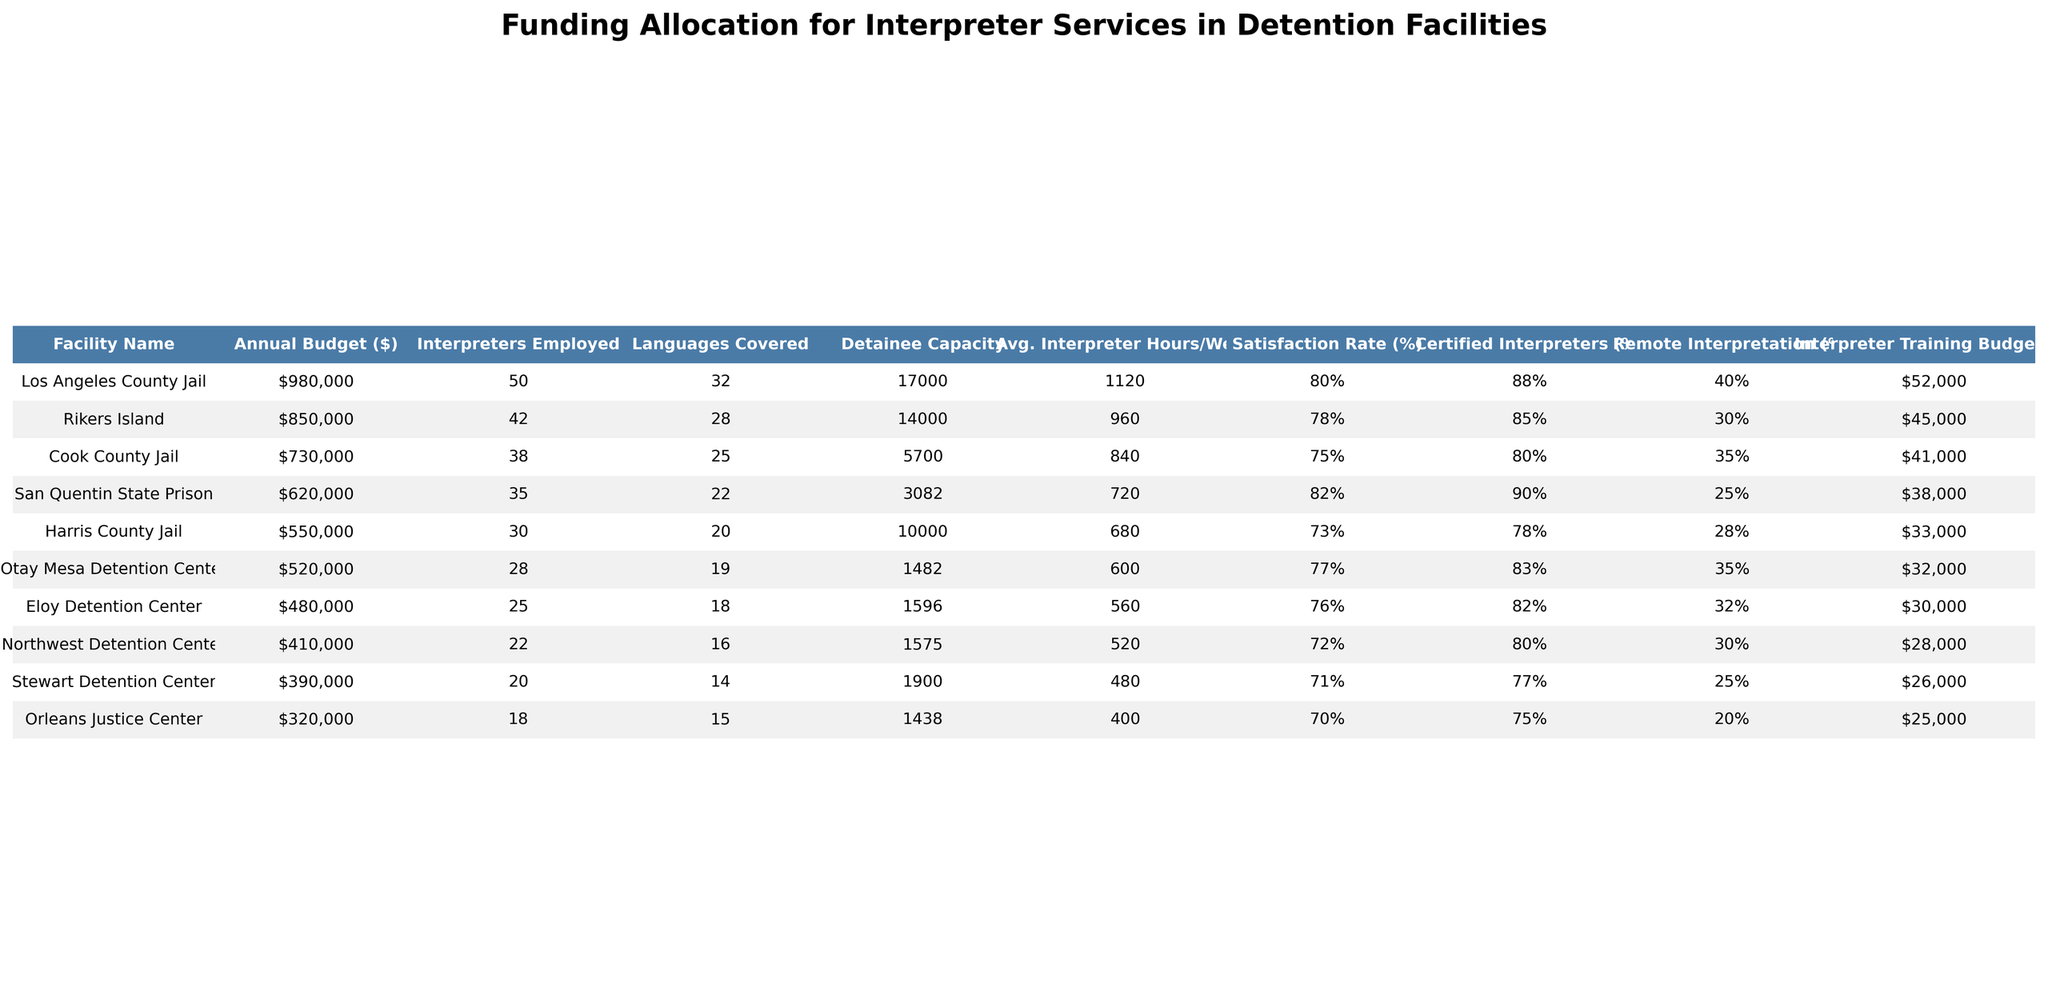what is the average annual budget for interpreter services across the facilities? To find the average, we sum the annual budgets of all facilities ($850,000 + $620,000 + $730,000 + $980,000 + $550,000 + $320,000 + $480,000 + $410,000 + $390,000 + $520,000 = $4,679,000) and divide by the number of facilities (10). The average is $4,679,000 / 10 = $467,900.
Answer: $467,900 which facility has the highest satisfaction rate? By examining the satisfaction rates listed, Rikers Island has a satisfaction rate of 78%, which is the highest among the facilities.
Answer: Rikers Island how many interpreters are employed at Cook County Jail? The table shows that Cook County Jail employs 38 interpreters.
Answer: 38 what is the total amount allocated for interpreter training across all facilities? Adding up the interpreter training budgets gives us ($45,000 + $38,000 + $41,000 + $52,000 + $33,000 + $25,000 + $30,000 + $28,000 + $26,000 + $32,000 = $400,000). Therefore, the total amount is $400,000.
Answer: $400,000 is the percentage of certified interpreters at Harris County Jail lower than the average? The average percentage of certified interpreters across all facilities is calculated as (85 + 90 + 80 + 88 + 78 + 75 + 82 + 80 + 77 + 83) / 10 = 80.8%. Harris County Jail's 78% is lower than this average.
Answer: Yes which facility has the largest detainee capacity? Upon reviewing the data, Los Angeles County Jail has a detainee capacity of 17,000, making it the facility with the largest capacity.
Answer: Los Angeles County Jail how does the percentage of remote interpretation services at Stewart Detention Center compare to the average? The average percentage of remote interpretation is calculated as (30 + 25 + 35 + 40 + 28 + 20 + 32 + 30 + 25 + 35) / 10 = 28. The Stewart Detention Center has a percentage of 25%, which is below the average.
Answer: Below average what is the difference in annual budget between the highest and lowest facilities? The highest annual budget is for Los Angeles County Jail at $980,000 and the lowest is Orleans Justice Center at $320,000. The difference is $980,000 - $320,000 = $660,000.
Answer: $660,000 which facility covers the most languages? By scanning the languages covered, Los Angeles County Jail covers 32 languages, which is the most among all listed facilities.
Answer: Los Angeles County Jail do any facilities have a satisfaction rate below 70%? Reviewing the satisfaction rates, the Orleans Justice Center has a satisfaction rate of 70%, which is the lowest. All other facilities have rates equal to or above 70%.
Answer: No what is the average number of interpreter hours per week across all facilities? Summing the average interpreter hours per week gives: (960 + 720 + 840 + 1120 + 680 + 400 + 560 + 520 + 480 + 600) = 5,680. Dividing by the number of facilities (10) results in an average of 5,680 / 10 = 568 hours per week.
Answer: 568 hours 